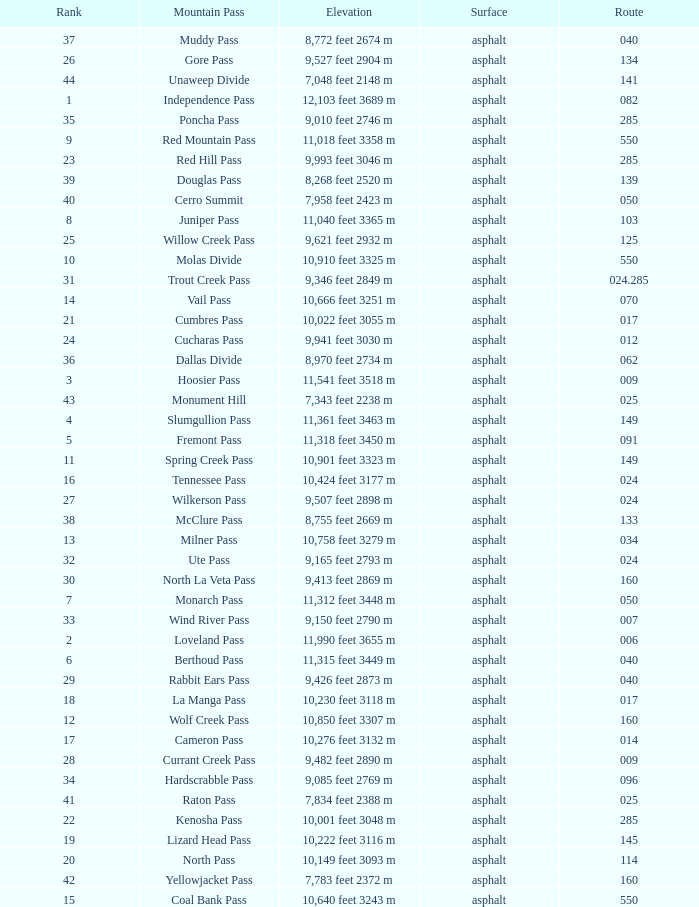What is the Surface of the Route less than 7? Asphalt. 